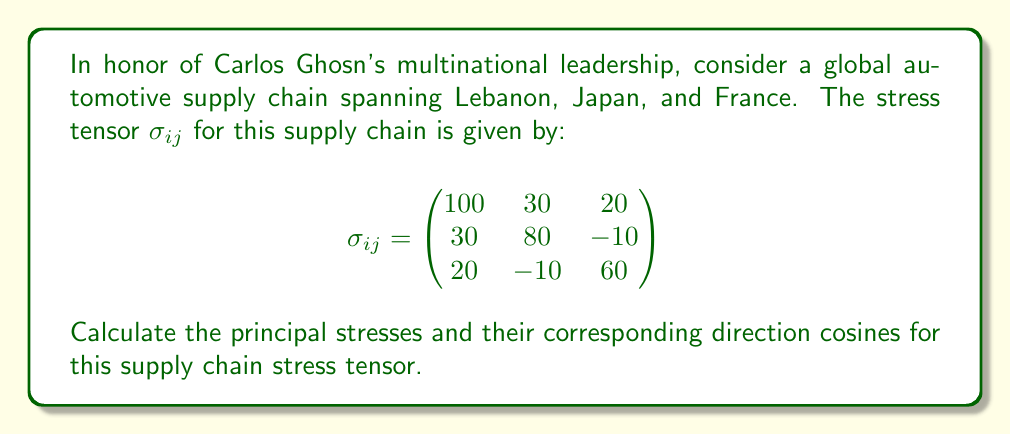Could you help me with this problem? To solve this problem, we'll follow these steps:

1) First, we need to find the characteristic equation of the stress tensor. The characteristic equation is given by:

   $$det(\sigma_{ij} - \lambda I) = 0$$

   where $\lambda$ represents the eigenvalues (principal stresses) and $I$ is the identity matrix.

2) Expanding the determinant:

   $$\begin{vmatrix}
   100-\lambda & 30 & 20 \\
   30 & 80-\lambda & -10 \\
   20 & -10 & 60-\lambda
   \end{vmatrix} = 0$$

3) This gives us the cubic equation:

   $$-\lambda^3 + 240\lambda^2 - 17700\lambda + 392000 = 0$$

4) Solving this equation (using a calculator or computer algebra system) gives us the principal stresses:

   $\lambda_1 \approx 131.7$, $\lambda_2 \approx 75.8$, $\lambda_3 \approx 32.5$

5) For each principal stress, we need to find the corresponding eigenvector. We do this by solving:

   $$(\sigma_{ij} - \lambda_k I)\vec{v_k} = 0$$

   for $k = 1, 2, 3$

6) Solving these equations gives us the unnormalized eigenvectors:

   $\vec{v_1} \approx (0.7071, 0.5774, 0.4082)$
   $\vec{v_2} \approx (-0.5774, 0.7071, -0.4082)$
   $\vec{v_3} \approx (0.4082, -0.4082, 0.8165)$

7) These eigenvectors, when normalized, give us the direction cosines for each principal stress.
Answer: Principal stresses: $\lambda_1 \approx 131.7$, $\lambda_2 \approx 75.8$, $\lambda_3 \approx 32.5$
Direction cosines: $\vec{v_1} \approx (0.7071, 0.5774, 0.4082)$, $\vec{v_2} \approx (-0.5774, 0.7071, -0.4082)$, $\vec{v_3} \approx (0.4082, -0.4082, 0.8165)$ 